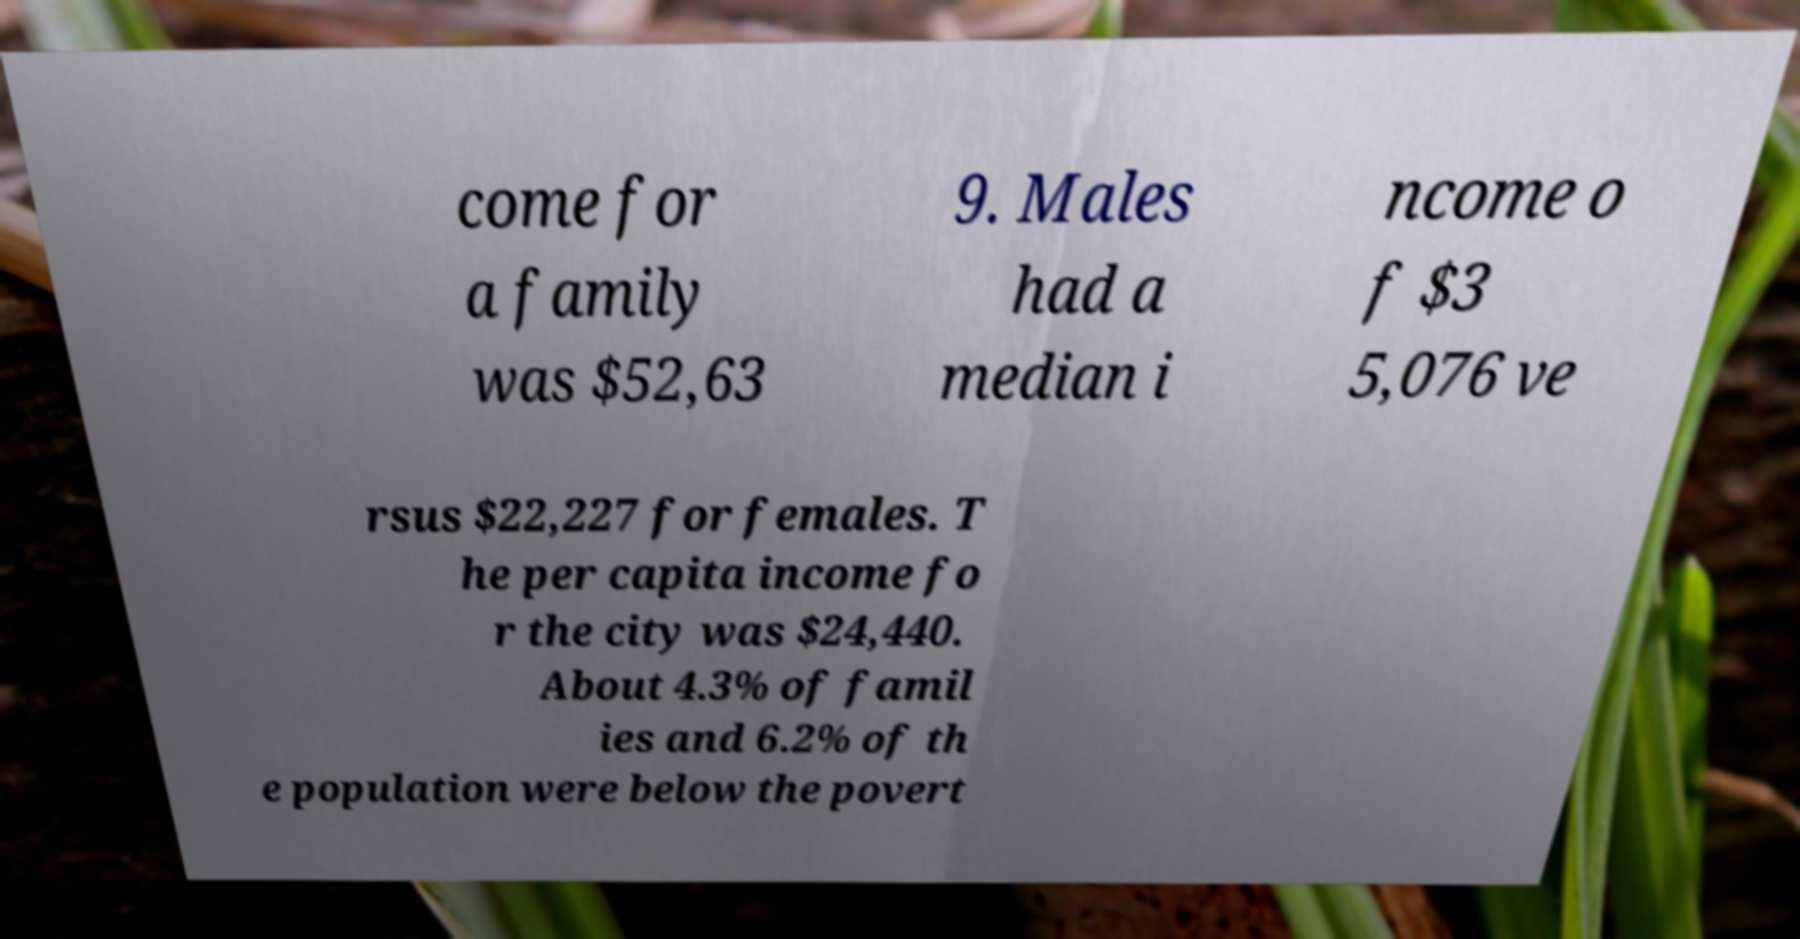Can you read and provide the text displayed in the image?This photo seems to have some interesting text. Can you extract and type it out for me? come for a family was $52,63 9. Males had a median i ncome o f $3 5,076 ve rsus $22,227 for females. T he per capita income fo r the city was $24,440. About 4.3% of famil ies and 6.2% of th e population were below the povert 